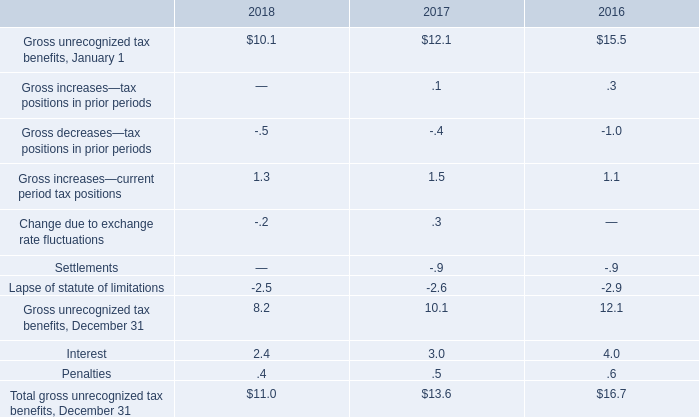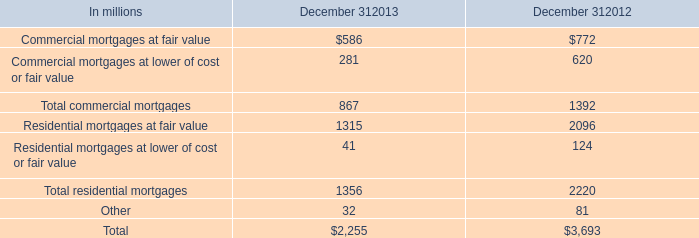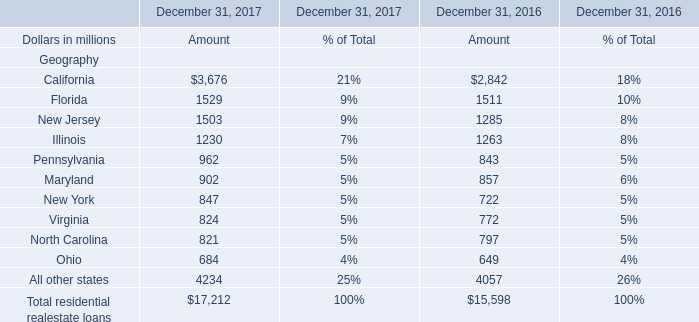what's the total amount of New Jersey of December 31, 2016 Amount, and Residential mortgages at fair value of December 312012 ? 
Computations: (1285.0 + 2096.0)
Answer: 3381.0. 